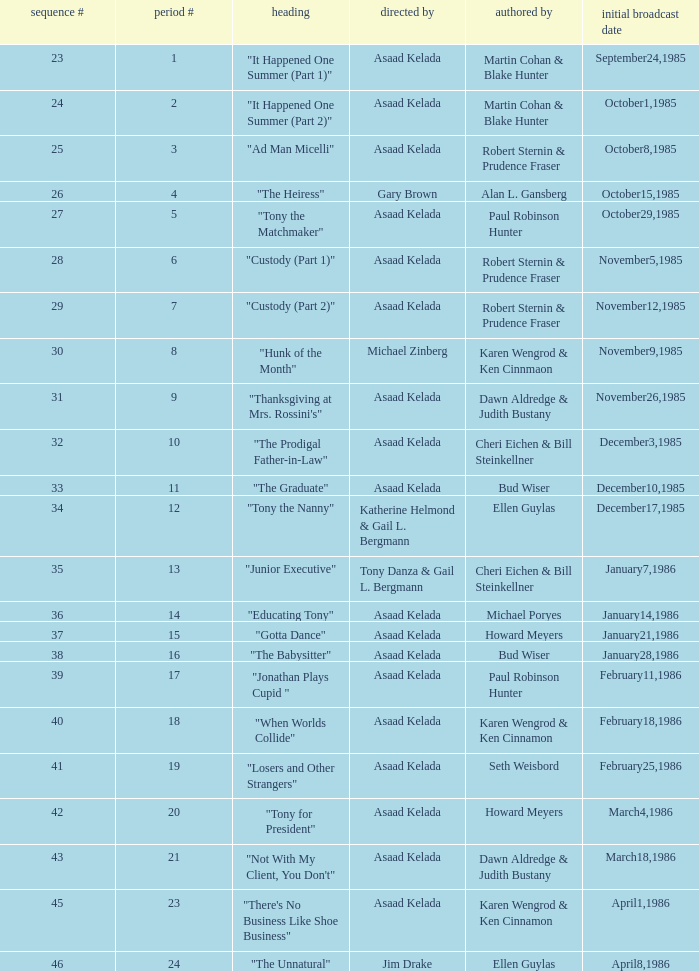What is the date of the episode written by Michael Poryes? January14,1986. 